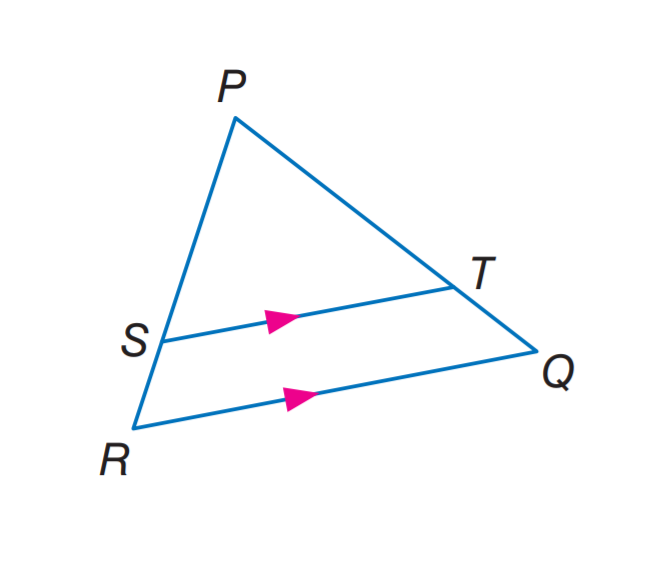Question: In \triangle P Q R, S T \parallel R Q. If P T = 7.5, T Q = 3, and S R = 2.5, find P S.
Choices:
A. 2.5
B. 6
C. 6.25
D. 7.5
Answer with the letter. Answer: C 